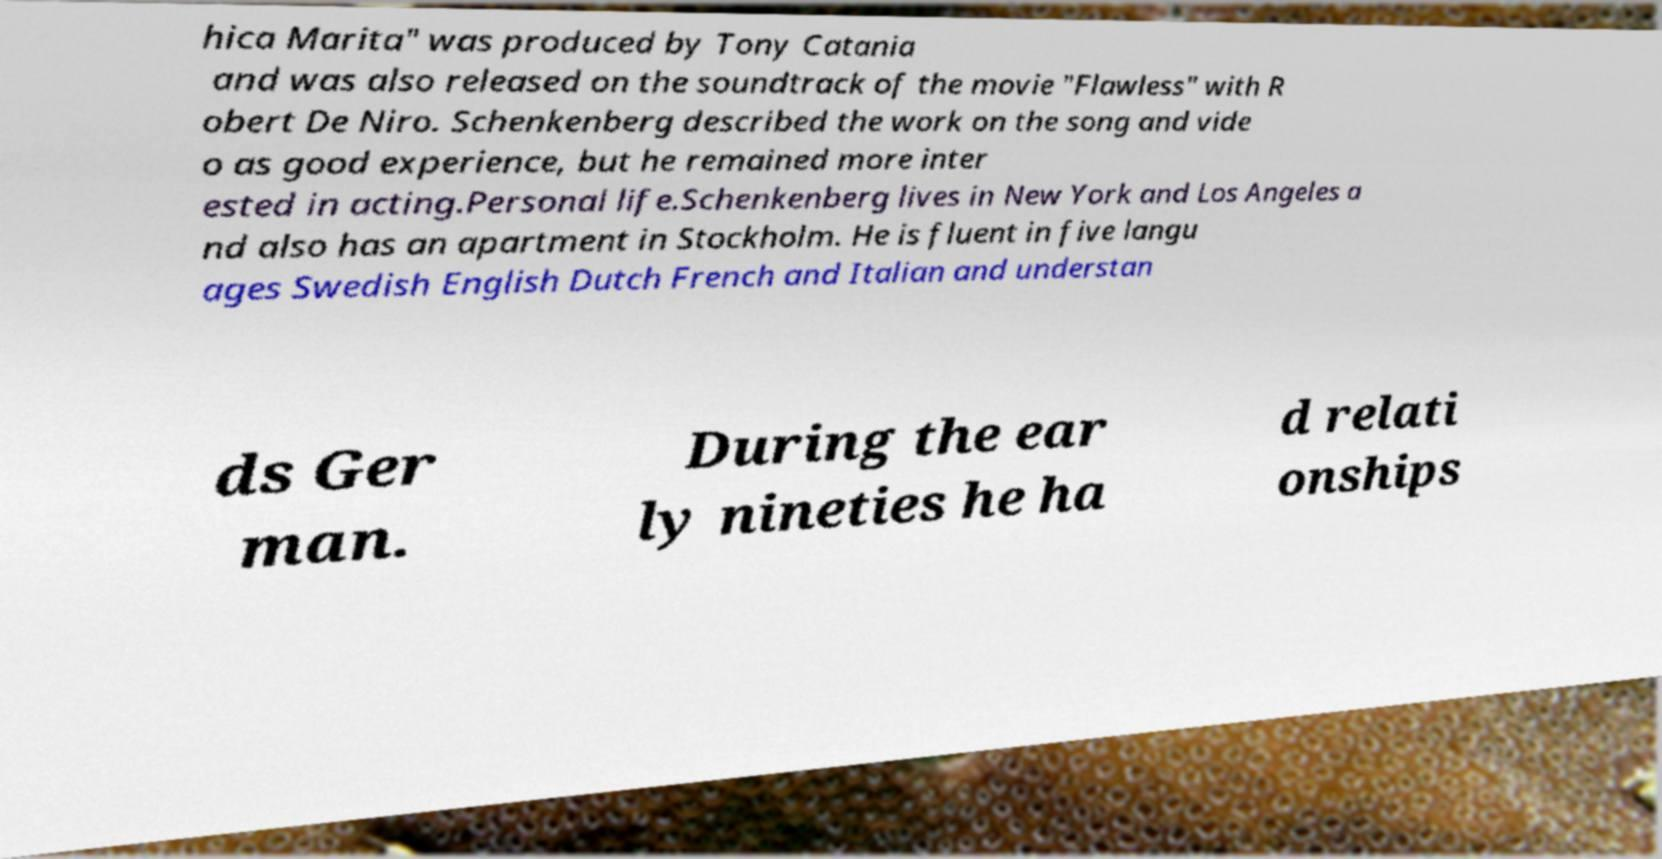I need the written content from this picture converted into text. Can you do that? hica Marita" was produced by Tony Catania and was also released on the soundtrack of the movie "Flawless" with R obert De Niro. Schenkenberg described the work on the song and vide o as good experience, but he remained more inter ested in acting.Personal life.Schenkenberg lives in New York and Los Angeles a nd also has an apartment in Stockholm. He is fluent in five langu ages Swedish English Dutch French and Italian and understan ds Ger man. During the ear ly nineties he ha d relati onships 